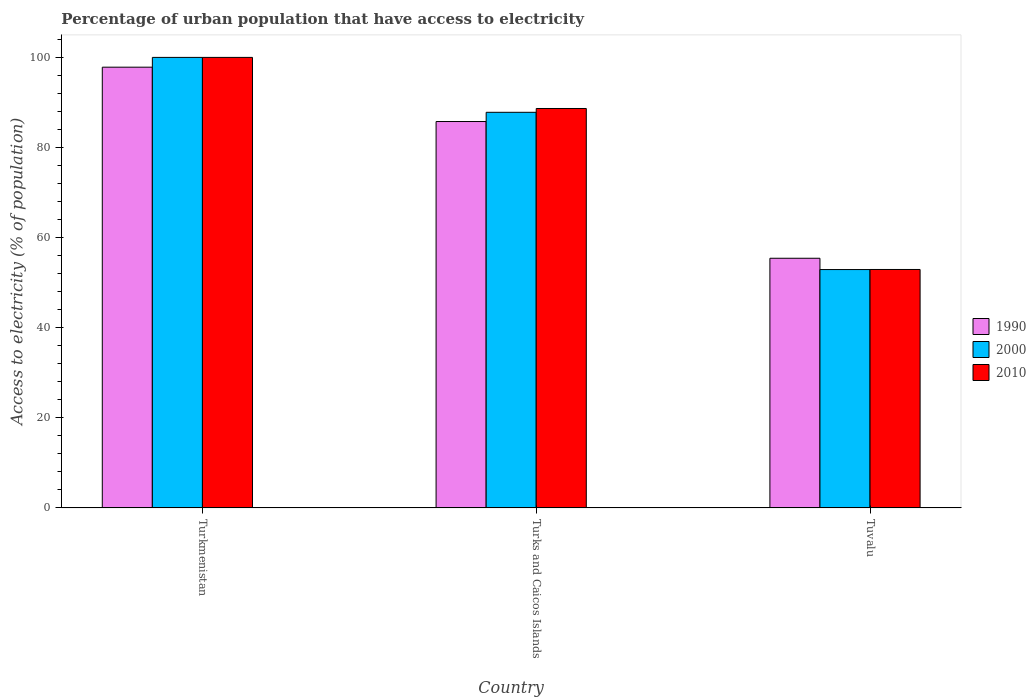How many different coloured bars are there?
Offer a terse response. 3. How many groups of bars are there?
Your response must be concise. 3. How many bars are there on the 3rd tick from the right?
Make the answer very short. 3. What is the label of the 3rd group of bars from the left?
Make the answer very short. Tuvalu. In how many cases, is the number of bars for a given country not equal to the number of legend labels?
Provide a succinct answer. 0. What is the percentage of urban population that have access to electricity in 1990 in Tuvalu?
Offer a very short reply. 55.42. Across all countries, what is the maximum percentage of urban population that have access to electricity in 2000?
Ensure brevity in your answer.  100. Across all countries, what is the minimum percentage of urban population that have access to electricity in 1990?
Your response must be concise. 55.42. In which country was the percentage of urban population that have access to electricity in 1990 maximum?
Offer a terse response. Turkmenistan. In which country was the percentage of urban population that have access to electricity in 1990 minimum?
Your answer should be very brief. Tuvalu. What is the total percentage of urban population that have access to electricity in 2000 in the graph?
Your answer should be compact. 240.72. What is the difference between the percentage of urban population that have access to electricity in 1990 in Turks and Caicos Islands and that in Tuvalu?
Your answer should be very brief. 30.35. What is the difference between the percentage of urban population that have access to electricity in 2000 in Turkmenistan and the percentage of urban population that have access to electricity in 2010 in Turks and Caicos Islands?
Make the answer very short. 11.34. What is the average percentage of urban population that have access to electricity in 1990 per country?
Offer a terse response. 79.67. What is the difference between the percentage of urban population that have access to electricity of/in 1990 and percentage of urban population that have access to electricity of/in 2010 in Turks and Caicos Islands?
Your answer should be compact. -2.89. In how many countries, is the percentage of urban population that have access to electricity in 1990 greater than 8 %?
Give a very brief answer. 3. What is the ratio of the percentage of urban population that have access to electricity in 2010 in Turkmenistan to that in Tuvalu?
Provide a short and direct response. 1.89. What is the difference between the highest and the second highest percentage of urban population that have access to electricity in 2000?
Offer a very short reply. 47.09. What is the difference between the highest and the lowest percentage of urban population that have access to electricity in 2000?
Offer a terse response. 47.09. What does the 1st bar from the right in Turks and Caicos Islands represents?
Your answer should be very brief. 2010. Is it the case that in every country, the sum of the percentage of urban population that have access to electricity in 2010 and percentage of urban population that have access to electricity in 2000 is greater than the percentage of urban population that have access to electricity in 1990?
Provide a short and direct response. Yes. How many countries are there in the graph?
Your answer should be compact. 3. Does the graph contain grids?
Keep it short and to the point. No. What is the title of the graph?
Your response must be concise. Percentage of urban population that have access to electricity. Does "1981" appear as one of the legend labels in the graph?
Your answer should be compact. No. What is the label or title of the X-axis?
Ensure brevity in your answer.  Country. What is the label or title of the Y-axis?
Keep it short and to the point. Access to electricity (% of population). What is the Access to electricity (% of population) in 1990 in Turkmenistan?
Your response must be concise. 97.83. What is the Access to electricity (% of population) of 2010 in Turkmenistan?
Keep it short and to the point. 100. What is the Access to electricity (% of population) in 1990 in Turks and Caicos Islands?
Keep it short and to the point. 85.77. What is the Access to electricity (% of population) of 2000 in Turks and Caicos Islands?
Offer a very short reply. 87.81. What is the Access to electricity (% of population) in 2010 in Turks and Caicos Islands?
Your answer should be compact. 88.66. What is the Access to electricity (% of population) of 1990 in Tuvalu?
Make the answer very short. 55.42. What is the Access to electricity (% of population) in 2000 in Tuvalu?
Offer a very short reply. 52.91. What is the Access to electricity (% of population) of 2010 in Tuvalu?
Your answer should be very brief. 52.93. Across all countries, what is the maximum Access to electricity (% of population) in 1990?
Your answer should be very brief. 97.83. Across all countries, what is the maximum Access to electricity (% of population) of 2010?
Provide a succinct answer. 100. Across all countries, what is the minimum Access to electricity (% of population) in 1990?
Your answer should be compact. 55.42. Across all countries, what is the minimum Access to electricity (% of population) in 2000?
Give a very brief answer. 52.91. Across all countries, what is the minimum Access to electricity (% of population) in 2010?
Keep it short and to the point. 52.93. What is the total Access to electricity (% of population) of 1990 in the graph?
Your answer should be very brief. 239.02. What is the total Access to electricity (% of population) of 2000 in the graph?
Your response must be concise. 240.72. What is the total Access to electricity (% of population) in 2010 in the graph?
Provide a short and direct response. 241.59. What is the difference between the Access to electricity (% of population) of 1990 in Turkmenistan and that in Turks and Caicos Islands?
Make the answer very short. 12.06. What is the difference between the Access to electricity (% of population) of 2000 in Turkmenistan and that in Turks and Caicos Islands?
Give a very brief answer. 12.19. What is the difference between the Access to electricity (% of population) in 2010 in Turkmenistan and that in Turks and Caicos Islands?
Offer a very short reply. 11.34. What is the difference between the Access to electricity (% of population) in 1990 in Turkmenistan and that in Tuvalu?
Offer a very short reply. 42.41. What is the difference between the Access to electricity (% of population) in 2000 in Turkmenistan and that in Tuvalu?
Your answer should be very brief. 47.09. What is the difference between the Access to electricity (% of population) of 2010 in Turkmenistan and that in Tuvalu?
Offer a terse response. 47.07. What is the difference between the Access to electricity (% of population) in 1990 in Turks and Caicos Islands and that in Tuvalu?
Your answer should be very brief. 30.35. What is the difference between the Access to electricity (% of population) in 2000 in Turks and Caicos Islands and that in Tuvalu?
Give a very brief answer. 34.9. What is the difference between the Access to electricity (% of population) of 2010 in Turks and Caicos Islands and that in Tuvalu?
Provide a short and direct response. 35.73. What is the difference between the Access to electricity (% of population) in 1990 in Turkmenistan and the Access to electricity (% of population) in 2000 in Turks and Caicos Islands?
Keep it short and to the point. 10.02. What is the difference between the Access to electricity (% of population) in 1990 in Turkmenistan and the Access to electricity (% of population) in 2010 in Turks and Caicos Islands?
Ensure brevity in your answer.  9.17. What is the difference between the Access to electricity (% of population) of 2000 in Turkmenistan and the Access to electricity (% of population) of 2010 in Turks and Caicos Islands?
Offer a very short reply. 11.34. What is the difference between the Access to electricity (% of population) in 1990 in Turkmenistan and the Access to electricity (% of population) in 2000 in Tuvalu?
Offer a very short reply. 44.92. What is the difference between the Access to electricity (% of population) in 1990 in Turkmenistan and the Access to electricity (% of population) in 2010 in Tuvalu?
Provide a succinct answer. 44.9. What is the difference between the Access to electricity (% of population) of 2000 in Turkmenistan and the Access to electricity (% of population) of 2010 in Tuvalu?
Your response must be concise. 47.07. What is the difference between the Access to electricity (% of population) of 1990 in Turks and Caicos Islands and the Access to electricity (% of population) of 2000 in Tuvalu?
Provide a succinct answer. 32.86. What is the difference between the Access to electricity (% of population) in 1990 in Turks and Caicos Islands and the Access to electricity (% of population) in 2010 in Tuvalu?
Give a very brief answer. 32.84. What is the difference between the Access to electricity (% of population) in 2000 in Turks and Caicos Islands and the Access to electricity (% of population) in 2010 in Tuvalu?
Provide a short and direct response. 34.88. What is the average Access to electricity (% of population) of 1990 per country?
Give a very brief answer. 79.67. What is the average Access to electricity (% of population) in 2000 per country?
Your response must be concise. 80.24. What is the average Access to electricity (% of population) of 2010 per country?
Ensure brevity in your answer.  80.53. What is the difference between the Access to electricity (% of population) in 1990 and Access to electricity (% of population) in 2000 in Turkmenistan?
Give a very brief answer. -2.17. What is the difference between the Access to electricity (% of population) in 1990 and Access to electricity (% of population) in 2010 in Turkmenistan?
Your response must be concise. -2.17. What is the difference between the Access to electricity (% of population) of 2000 and Access to electricity (% of population) of 2010 in Turkmenistan?
Your answer should be very brief. 0. What is the difference between the Access to electricity (% of population) of 1990 and Access to electricity (% of population) of 2000 in Turks and Caicos Islands?
Ensure brevity in your answer.  -2.04. What is the difference between the Access to electricity (% of population) of 1990 and Access to electricity (% of population) of 2010 in Turks and Caicos Islands?
Your response must be concise. -2.89. What is the difference between the Access to electricity (% of population) of 2000 and Access to electricity (% of population) of 2010 in Turks and Caicos Islands?
Offer a terse response. -0.85. What is the difference between the Access to electricity (% of population) in 1990 and Access to electricity (% of population) in 2000 in Tuvalu?
Keep it short and to the point. 2.51. What is the difference between the Access to electricity (% of population) of 1990 and Access to electricity (% of population) of 2010 in Tuvalu?
Offer a terse response. 2.49. What is the difference between the Access to electricity (% of population) in 2000 and Access to electricity (% of population) in 2010 in Tuvalu?
Offer a very short reply. -0.02. What is the ratio of the Access to electricity (% of population) of 1990 in Turkmenistan to that in Turks and Caicos Islands?
Offer a terse response. 1.14. What is the ratio of the Access to electricity (% of population) of 2000 in Turkmenistan to that in Turks and Caicos Islands?
Your answer should be very brief. 1.14. What is the ratio of the Access to electricity (% of population) in 2010 in Turkmenistan to that in Turks and Caicos Islands?
Make the answer very short. 1.13. What is the ratio of the Access to electricity (% of population) in 1990 in Turkmenistan to that in Tuvalu?
Your response must be concise. 1.77. What is the ratio of the Access to electricity (% of population) of 2000 in Turkmenistan to that in Tuvalu?
Ensure brevity in your answer.  1.89. What is the ratio of the Access to electricity (% of population) of 2010 in Turkmenistan to that in Tuvalu?
Your response must be concise. 1.89. What is the ratio of the Access to electricity (% of population) of 1990 in Turks and Caicos Islands to that in Tuvalu?
Your response must be concise. 1.55. What is the ratio of the Access to electricity (% of population) in 2000 in Turks and Caicos Islands to that in Tuvalu?
Offer a very short reply. 1.66. What is the ratio of the Access to electricity (% of population) in 2010 in Turks and Caicos Islands to that in Tuvalu?
Ensure brevity in your answer.  1.68. What is the difference between the highest and the second highest Access to electricity (% of population) in 1990?
Offer a terse response. 12.06. What is the difference between the highest and the second highest Access to electricity (% of population) of 2000?
Your response must be concise. 12.19. What is the difference between the highest and the second highest Access to electricity (% of population) of 2010?
Make the answer very short. 11.34. What is the difference between the highest and the lowest Access to electricity (% of population) in 1990?
Provide a short and direct response. 42.41. What is the difference between the highest and the lowest Access to electricity (% of population) in 2000?
Give a very brief answer. 47.09. What is the difference between the highest and the lowest Access to electricity (% of population) of 2010?
Offer a terse response. 47.07. 